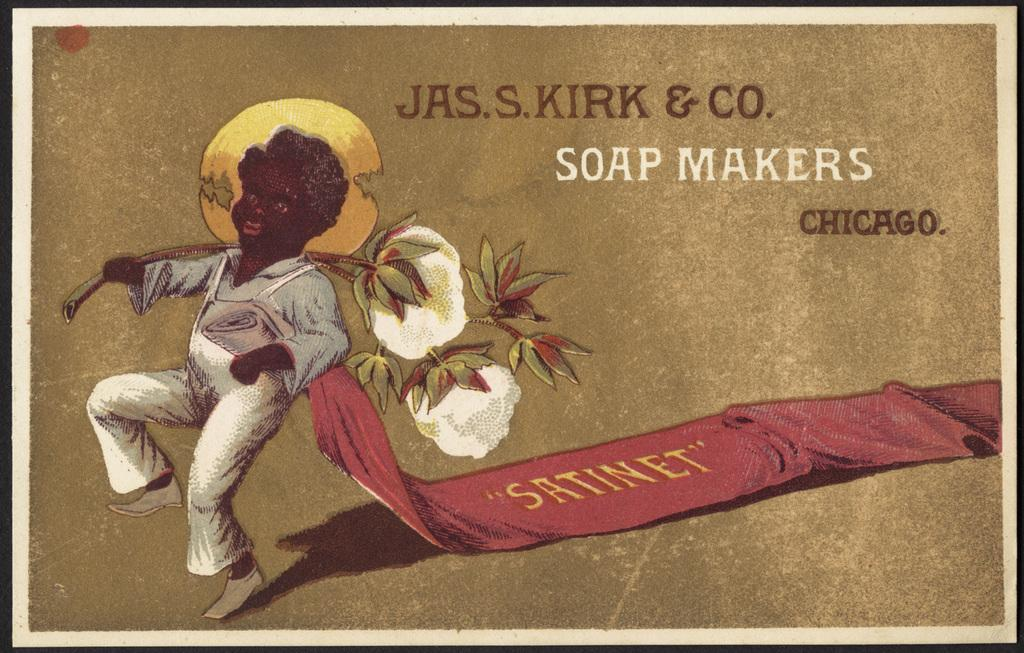What is the main subject of the image? The main subject of the image is a cover page. What can be found on the cover page? The cover page contains text and a person depicted on it. What type of appliance is being used by the person on the cover page? There is no appliance visible in the image; it only shows a cover page with text and a person depicted on it. 